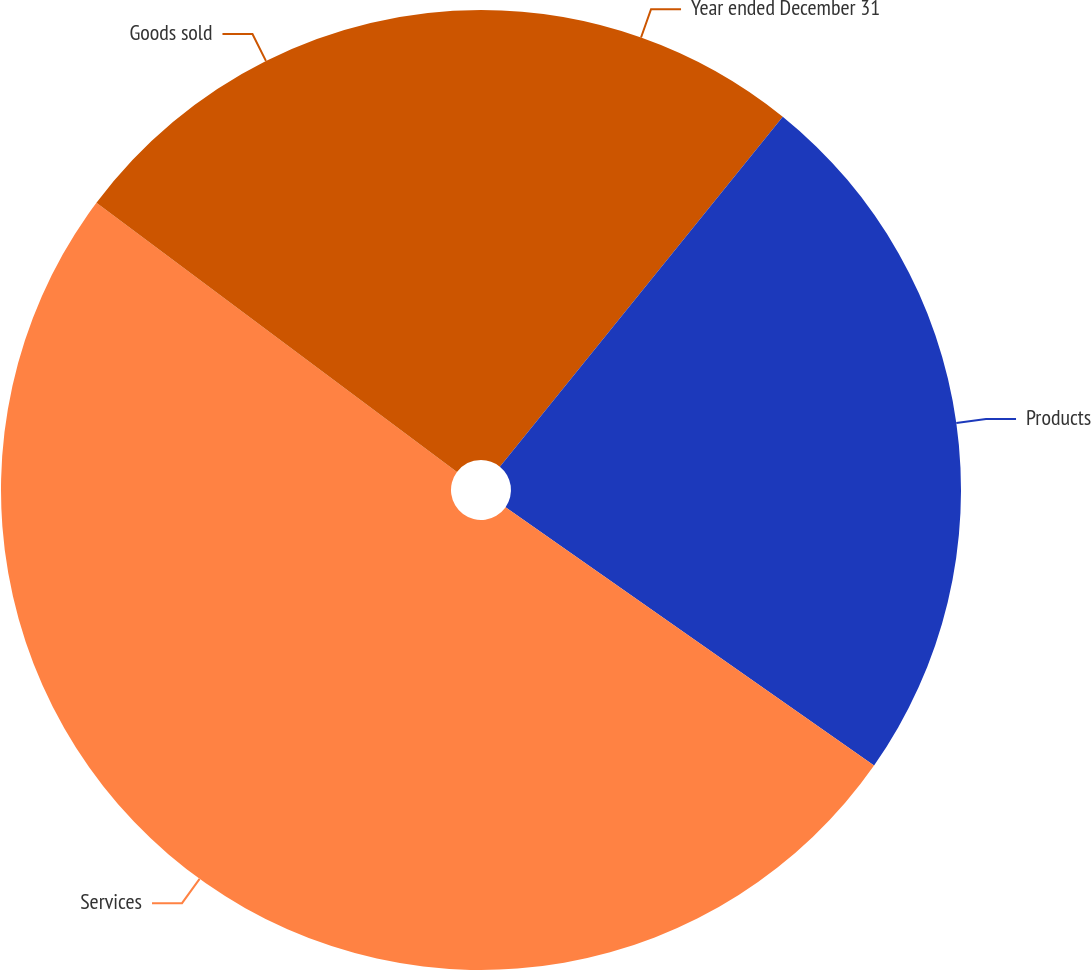Convert chart to OTSL. <chart><loc_0><loc_0><loc_500><loc_500><pie_chart><fcel>Year ended December 31<fcel>Products<fcel>Services<fcel>Goods sold<nl><fcel>10.82%<fcel>23.91%<fcel>50.48%<fcel>14.79%<nl></chart> 